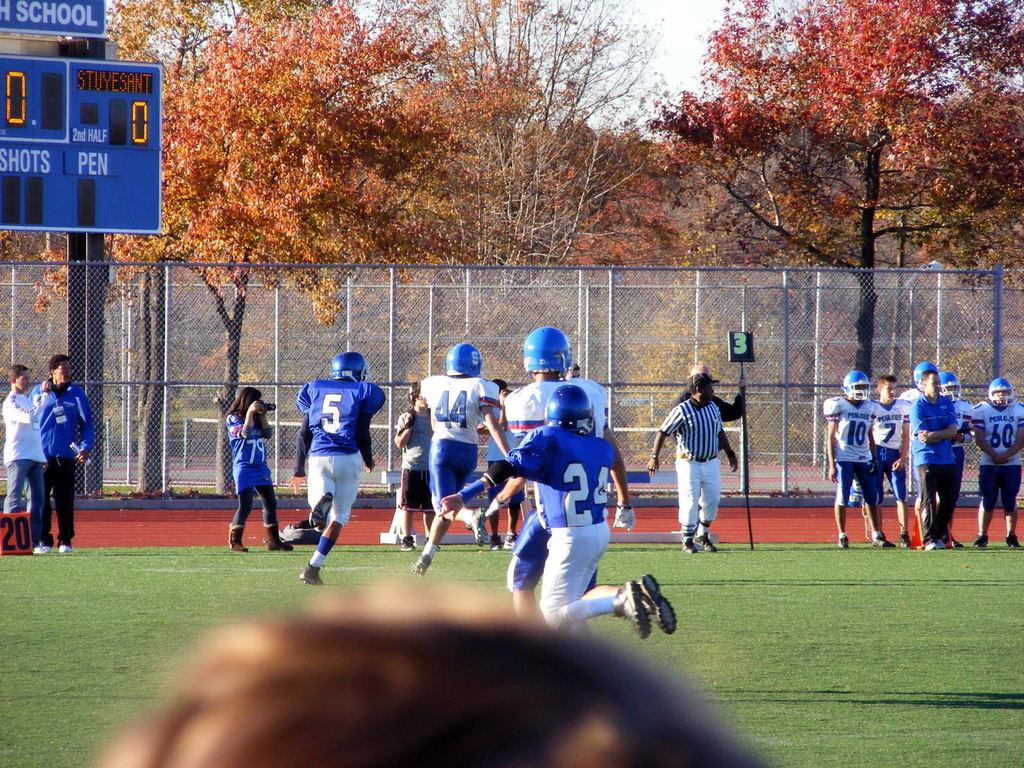What is happening in the image involving the group of people? The people in the image are playing. What can be seen in the middle of the image? There is a fence in the middle of the image. What type of vegetation is visible in the background of the image? There are trees in the background of the image. What is the ground covered with in the image? The ground is covered with grass. What type of jar can be seen on the ground in the image? There is no jar present on the ground in the image. How low are the clouds in the image? There are no clouds visible in the image. 